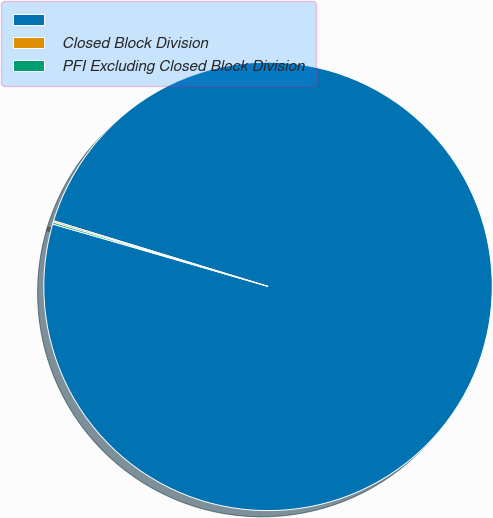Convert chart to OTSL. <chart><loc_0><loc_0><loc_500><loc_500><pie_chart><ecel><fcel>Closed Block Division<fcel>PFI Excluding Closed Block Division<nl><fcel>99.76%<fcel>0.11%<fcel>0.13%<nl></chart> 